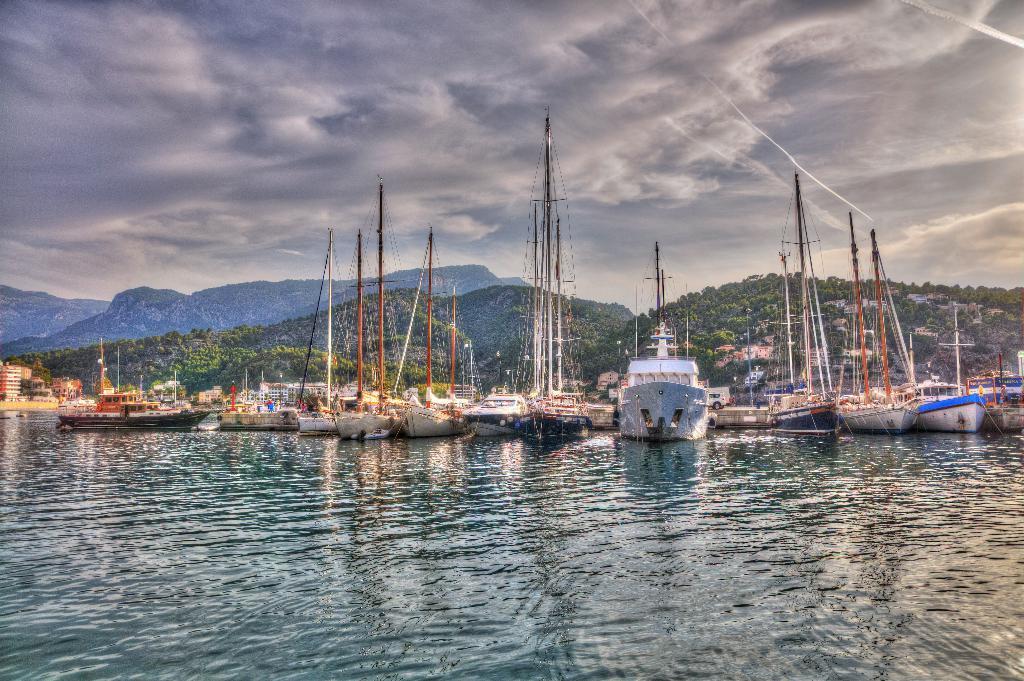Please provide a concise description of this image. In this picture we can observe a fleet on the water. There are some poles. In the background we can observe trees and hills. We can observe a sky with some clouds. 